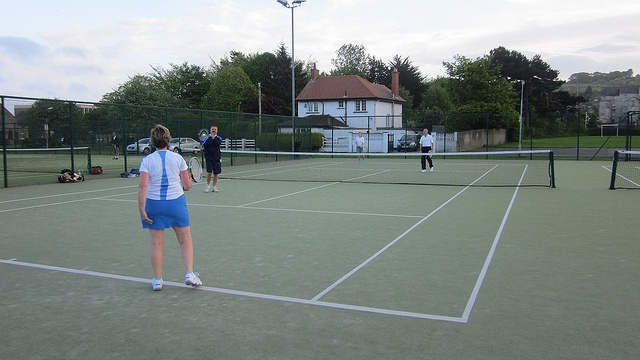Describe the objects in this image and their specific colors. I can see people in lavender, blue, darkgray, and gray tones, people in lavender, black, gray, and darkgray tones, people in lavender, black, darkgray, and gray tones, car in lavender, darkgray, gray, and black tones, and car in lavender, black, gray, darkblue, and navy tones in this image. 